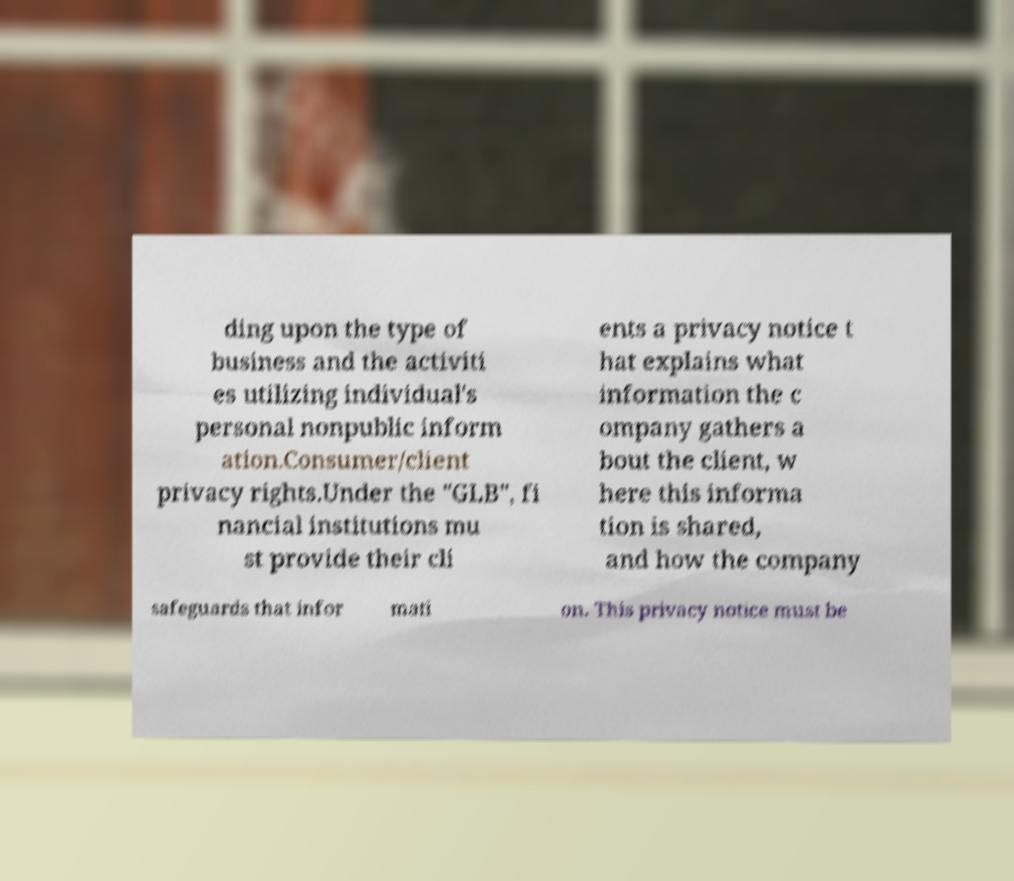For documentation purposes, I need the text within this image transcribed. Could you provide that? ding upon the type of business and the activiti es utilizing individual's personal nonpublic inform ation.Consumer/client privacy rights.Under the "GLB", fi nancial institutions mu st provide their cli ents a privacy notice t hat explains what information the c ompany gathers a bout the client, w here this informa tion is shared, and how the company safeguards that infor mati on. This privacy notice must be 